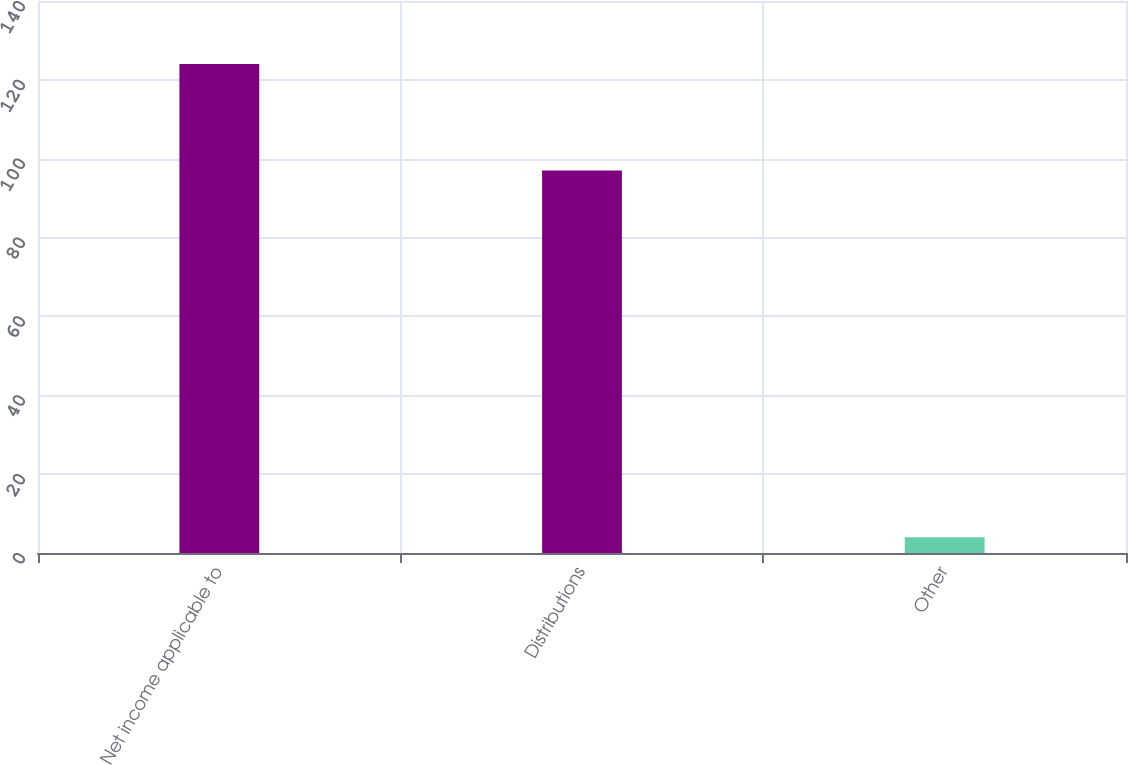<chart> <loc_0><loc_0><loc_500><loc_500><bar_chart><fcel>Net income applicable to<fcel>Distributions<fcel>Other<nl><fcel>124<fcel>97<fcel>4<nl></chart> 